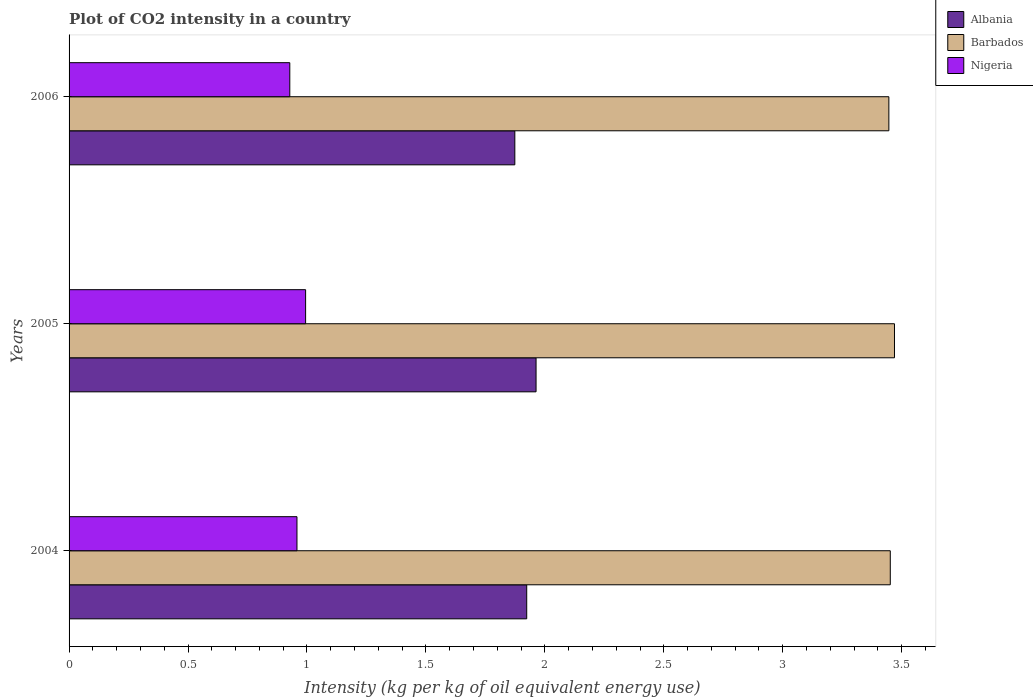How many different coloured bars are there?
Offer a very short reply. 3. How many groups of bars are there?
Offer a terse response. 3. Are the number of bars per tick equal to the number of legend labels?
Give a very brief answer. Yes. How many bars are there on the 1st tick from the bottom?
Your answer should be very brief. 3. What is the CO2 intensity in in Nigeria in 2005?
Your answer should be compact. 0.99. Across all years, what is the maximum CO2 intensity in in Barbados?
Provide a short and direct response. 3.47. Across all years, what is the minimum CO2 intensity in in Nigeria?
Make the answer very short. 0.93. In which year was the CO2 intensity in in Albania maximum?
Keep it short and to the point. 2005. What is the total CO2 intensity in in Albania in the graph?
Ensure brevity in your answer.  5.76. What is the difference between the CO2 intensity in in Barbados in 2004 and that in 2005?
Your answer should be very brief. -0.02. What is the difference between the CO2 intensity in in Barbados in 2004 and the CO2 intensity in in Albania in 2005?
Your answer should be compact. 1.49. What is the average CO2 intensity in in Albania per year?
Your response must be concise. 1.92. In the year 2006, what is the difference between the CO2 intensity in in Barbados and CO2 intensity in in Albania?
Keep it short and to the point. 1.57. In how many years, is the CO2 intensity in in Barbados greater than 2.7 kg?
Provide a succinct answer. 3. What is the ratio of the CO2 intensity in in Nigeria in 2004 to that in 2005?
Your response must be concise. 0.96. Is the CO2 intensity in in Nigeria in 2004 less than that in 2005?
Offer a terse response. Yes. What is the difference between the highest and the second highest CO2 intensity in in Albania?
Provide a succinct answer. 0.04. What is the difference between the highest and the lowest CO2 intensity in in Nigeria?
Your answer should be compact. 0.07. In how many years, is the CO2 intensity in in Barbados greater than the average CO2 intensity in in Barbados taken over all years?
Your answer should be compact. 1. What does the 3rd bar from the top in 2005 represents?
Your answer should be compact. Albania. What does the 1st bar from the bottom in 2005 represents?
Provide a succinct answer. Albania. Is it the case that in every year, the sum of the CO2 intensity in in Barbados and CO2 intensity in in Nigeria is greater than the CO2 intensity in in Albania?
Provide a succinct answer. Yes. How many bars are there?
Give a very brief answer. 9. Does the graph contain any zero values?
Make the answer very short. No. Where does the legend appear in the graph?
Offer a very short reply. Top right. How many legend labels are there?
Ensure brevity in your answer.  3. How are the legend labels stacked?
Offer a very short reply. Vertical. What is the title of the graph?
Keep it short and to the point. Plot of CO2 intensity in a country. What is the label or title of the X-axis?
Give a very brief answer. Intensity (kg per kg of oil equivalent energy use). What is the Intensity (kg per kg of oil equivalent energy use) of Albania in 2004?
Offer a very short reply. 1.92. What is the Intensity (kg per kg of oil equivalent energy use) of Barbados in 2004?
Provide a short and direct response. 3.45. What is the Intensity (kg per kg of oil equivalent energy use) of Nigeria in 2004?
Offer a very short reply. 0.96. What is the Intensity (kg per kg of oil equivalent energy use) of Albania in 2005?
Your response must be concise. 1.96. What is the Intensity (kg per kg of oil equivalent energy use) in Barbados in 2005?
Provide a short and direct response. 3.47. What is the Intensity (kg per kg of oil equivalent energy use) in Nigeria in 2005?
Your answer should be compact. 0.99. What is the Intensity (kg per kg of oil equivalent energy use) of Albania in 2006?
Your answer should be compact. 1.87. What is the Intensity (kg per kg of oil equivalent energy use) in Barbados in 2006?
Keep it short and to the point. 3.45. What is the Intensity (kg per kg of oil equivalent energy use) in Nigeria in 2006?
Your answer should be compact. 0.93. Across all years, what is the maximum Intensity (kg per kg of oil equivalent energy use) of Albania?
Your response must be concise. 1.96. Across all years, what is the maximum Intensity (kg per kg of oil equivalent energy use) in Barbados?
Provide a short and direct response. 3.47. Across all years, what is the maximum Intensity (kg per kg of oil equivalent energy use) of Nigeria?
Make the answer very short. 0.99. Across all years, what is the minimum Intensity (kg per kg of oil equivalent energy use) of Albania?
Provide a succinct answer. 1.87. Across all years, what is the minimum Intensity (kg per kg of oil equivalent energy use) in Barbados?
Provide a succinct answer. 3.45. Across all years, what is the minimum Intensity (kg per kg of oil equivalent energy use) in Nigeria?
Give a very brief answer. 0.93. What is the total Intensity (kg per kg of oil equivalent energy use) of Albania in the graph?
Ensure brevity in your answer.  5.76. What is the total Intensity (kg per kg of oil equivalent energy use) of Barbados in the graph?
Keep it short and to the point. 10.37. What is the total Intensity (kg per kg of oil equivalent energy use) of Nigeria in the graph?
Keep it short and to the point. 2.88. What is the difference between the Intensity (kg per kg of oil equivalent energy use) in Albania in 2004 and that in 2005?
Your response must be concise. -0.04. What is the difference between the Intensity (kg per kg of oil equivalent energy use) in Barbados in 2004 and that in 2005?
Make the answer very short. -0.02. What is the difference between the Intensity (kg per kg of oil equivalent energy use) in Nigeria in 2004 and that in 2005?
Your response must be concise. -0.04. What is the difference between the Intensity (kg per kg of oil equivalent energy use) of Albania in 2004 and that in 2006?
Offer a terse response. 0.05. What is the difference between the Intensity (kg per kg of oil equivalent energy use) in Barbados in 2004 and that in 2006?
Keep it short and to the point. 0.01. What is the difference between the Intensity (kg per kg of oil equivalent energy use) in Nigeria in 2004 and that in 2006?
Your answer should be very brief. 0.03. What is the difference between the Intensity (kg per kg of oil equivalent energy use) in Albania in 2005 and that in 2006?
Ensure brevity in your answer.  0.09. What is the difference between the Intensity (kg per kg of oil equivalent energy use) in Barbados in 2005 and that in 2006?
Provide a succinct answer. 0.02. What is the difference between the Intensity (kg per kg of oil equivalent energy use) of Nigeria in 2005 and that in 2006?
Provide a short and direct response. 0.07. What is the difference between the Intensity (kg per kg of oil equivalent energy use) of Albania in 2004 and the Intensity (kg per kg of oil equivalent energy use) of Barbados in 2005?
Offer a terse response. -1.55. What is the difference between the Intensity (kg per kg of oil equivalent energy use) in Albania in 2004 and the Intensity (kg per kg of oil equivalent energy use) in Nigeria in 2005?
Ensure brevity in your answer.  0.93. What is the difference between the Intensity (kg per kg of oil equivalent energy use) in Barbados in 2004 and the Intensity (kg per kg of oil equivalent energy use) in Nigeria in 2005?
Your response must be concise. 2.46. What is the difference between the Intensity (kg per kg of oil equivalent energy use) in Albania in 2004 and the Intensity (kg per kg of oil equivalent energy use) in Barbados in 2006?
Keep it short and to the point. -1.52. What is the difference between the Intensity (kg per kg of oil equivalent energy use) in Albania in 2004 and the Intensity (kg per kg of oil equivalent energy use) in Nigeria in 2006?
Make the answer very short. 1. What is the difference between the Intensity (kg per kg of oil equivalent energy use) in Barbados in 2004 and the Intensity (kg per kg of oil equivalent energy use) in Nigeria in 2006?
Your answer should be compact. 2.52. What is the difference between the Intensity (kg per kg of oil equivalent energy use) of Albania in 2005 and the Intensity (kg per kg of oil equivalent energy use) of Barbados in 2006?
Make the answer very short. -1.48. What is the difference between the Intensity (kg per kg of oil equivalent energy use) in Albania in 2005 and the Intensity (kg per kg of oil equivalent energy use) in Nigeria in 2006?
Make the answer very short. 1.04. What is the difference between the Intensity (kg per kg of oil equivalent energy use) of Barbados in 2005 and the Intensity (kg per kg of oil equivalent energy use) of Nigeria in 2006?
Make the answer very short. 2.54. What is the average Intensity (kg per kg of oil equivalent energy use) of Albania per year?
Offer a very short reply. 1.92. What is the average Intensity (kg per kg of oil equivalent energy use) of Barbados per year?
Provide a succinct answer. 3.46. What is the average Intensity (kg per kg of oil equivalent energy use) of Nigeria per year?
Your answer should be very brief. 0.96. In the year 2004, what is the difference between the Intensity (kg per kg of oil equivalent energy use) in Albania and Intensity (kg per kg of oil equivalent energy use) in Barbados?
Give a very brief answer. -1.53. In the year 2004, what is the difference between the Intensity (kg per kg of oil equivalent energy use) in Albania and Intensity (kg per kg of oil equivalent energy use) in Nigeria?
Make the answer very short. 0.97. In the year 2004, what is the difference between the Intensity (kg per kg of oil equivalent energy use) of Barbados and Intensity (kg per kg of oil equivalent energy use) of Nigeria?
Your answer should be very brief. 2.49. In the year 2005, what is the difference between the Intensity (kg per kg of oil equivalent energy use) in Albania and Intensity (kg per kg of oil equivalent energy use) in Barbados?
Your answer should be very brief. -1.51. In the year 2005, what is the difference between the Intensity (kg per kg of oil equivalent energy use) of Albania and Intensity (kg per kg of oil equivalent energy use) of Nigeria?
Your answer should be compact. 0.97. In the year 2005, what is the difference between the Intensity (kg per kg of oil equivalent energy use) of Barbados and Intensity (kg per kg of oil equivalent energy use) of Nigeria?
Your response must be concise. 2.48. In the year 2006, what is the difference between the Intensity (kg per kg of oil equivalent energy use) of Albania and Intensity (kg per kg of oil equivalent energy use) of Barbados?
Give a very brief answer. -1.57. In the year 2006, what is the difference between the Intensity (kg per kg of oil equivalent energy use) of Albania and Intensity (kg per kg of oil equivalent energy use) of Nigeria?
Your answer should be compact. 0.95. In the year 2006, what is the difference between the Intensity (kg per kg of oil equivalent energy use) of Barbados and Intensity (kg per kg of oil equivalent energy use) of Nigeria?
Provide a short and direct response. 2.52. What is the ratio of the Intensity (kg per kg of oil equivalent energy use) in Nigeria in 2004 to that in 2005?
Keep it short and to the point. 0.96. What is the ratio of the Intensity (kg per kg of oil equivalent energy use) of Albania in 2004 to that in 2006?
Ensure brevity in your answer.  1.03. What is the ratio of the Intensity (kg per kg of oil equivalent energy use) of Nigeria in 2004 to that in 2006?
Ensure brevity in your answer.  1.03. What is the ratio of the Intensity (kg per kg of oil equivalent energy use) in Albania in 2005 to that in 2006?
Your answer should be compact. 1.05. What is the ratio of the Intensity (kg per kg of oil equivalent energy use) in Barbados in 2005 to that in 2006?
Keep it short and to the point. 1.01. What is the ratio of the Intensity (kg per kg of oil equivalent energy use) of Nigeria in 2005 to that in 2006?
Your answer should be compact. 1.07. What is the difference between the highest and the second highest Intensity (kg per kg of oil equivalent energy use) of Albania?
Keep it short and to the point. 0.04. What is the difference between the highest and the second highest Intensity (kg per kg of oil equivalent energy use) in Barbados?
Offer a very short reply. 0.02. What is the difference between the highest and the second highest Intensity (kg per kg of oil equivalent energy use) in Nigeria?
Your answer should be compact. 0.04. What is the difference between the highest and the lowest Intensity (kg per kg of oil equivalent energy use) in Albania?
Give a very brief answer. 0.09. What is the difference between the highest and the lowest Intensity (kg per kg of oil equivalent energy use) of Barbados?
Your answer should be compact. 0.02. What is the difference between the highest and the lowest Intensity (kg per kg of oil equivalent energy use) in Nigeria?
Your response must be concise. 0.07. 